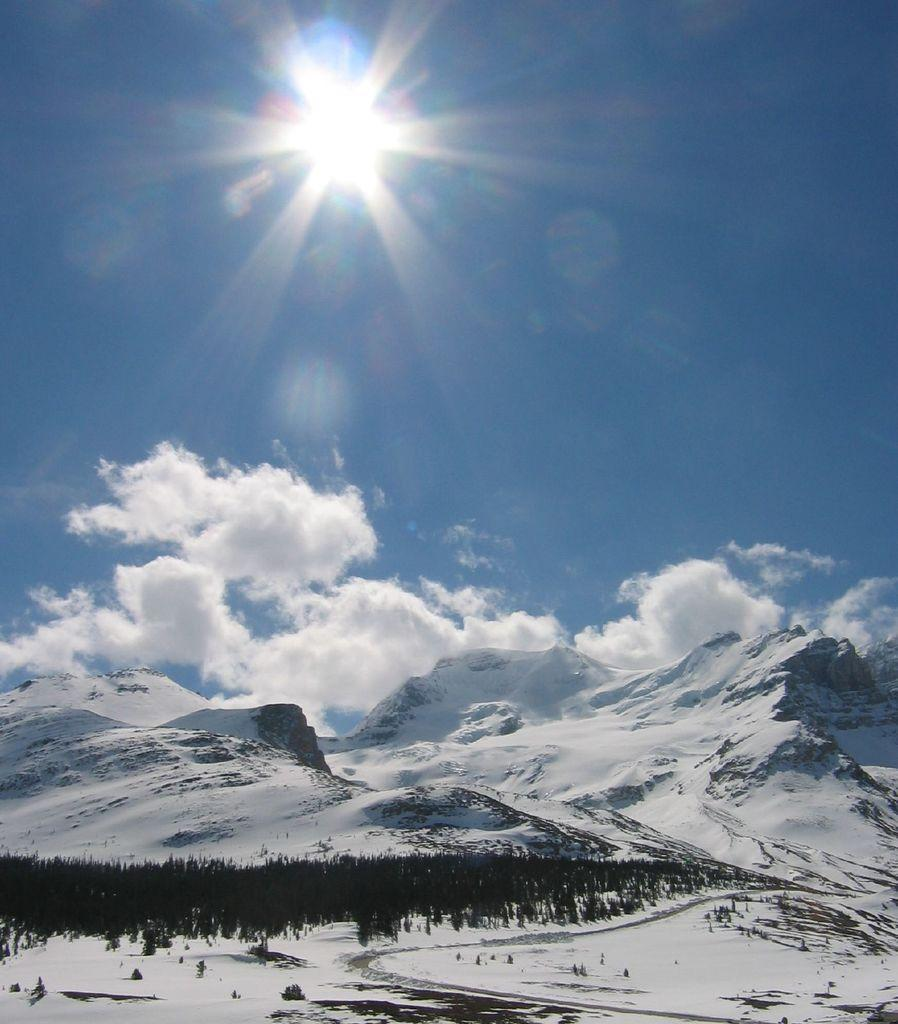What type of natural landscape is depicted in the image? The image features mountains. What other natural elements can be seen in the image? There are trees and clouds visible in the image. What is visible in the sky in the image? The sky is visible in the image, and the sun is also visible. What hobbies do the parents of the trees in the image have? There are no parents mentioned in the image, as trees do not have parents. Additionally, there is no information about the hobbies of any individuals in the image. 